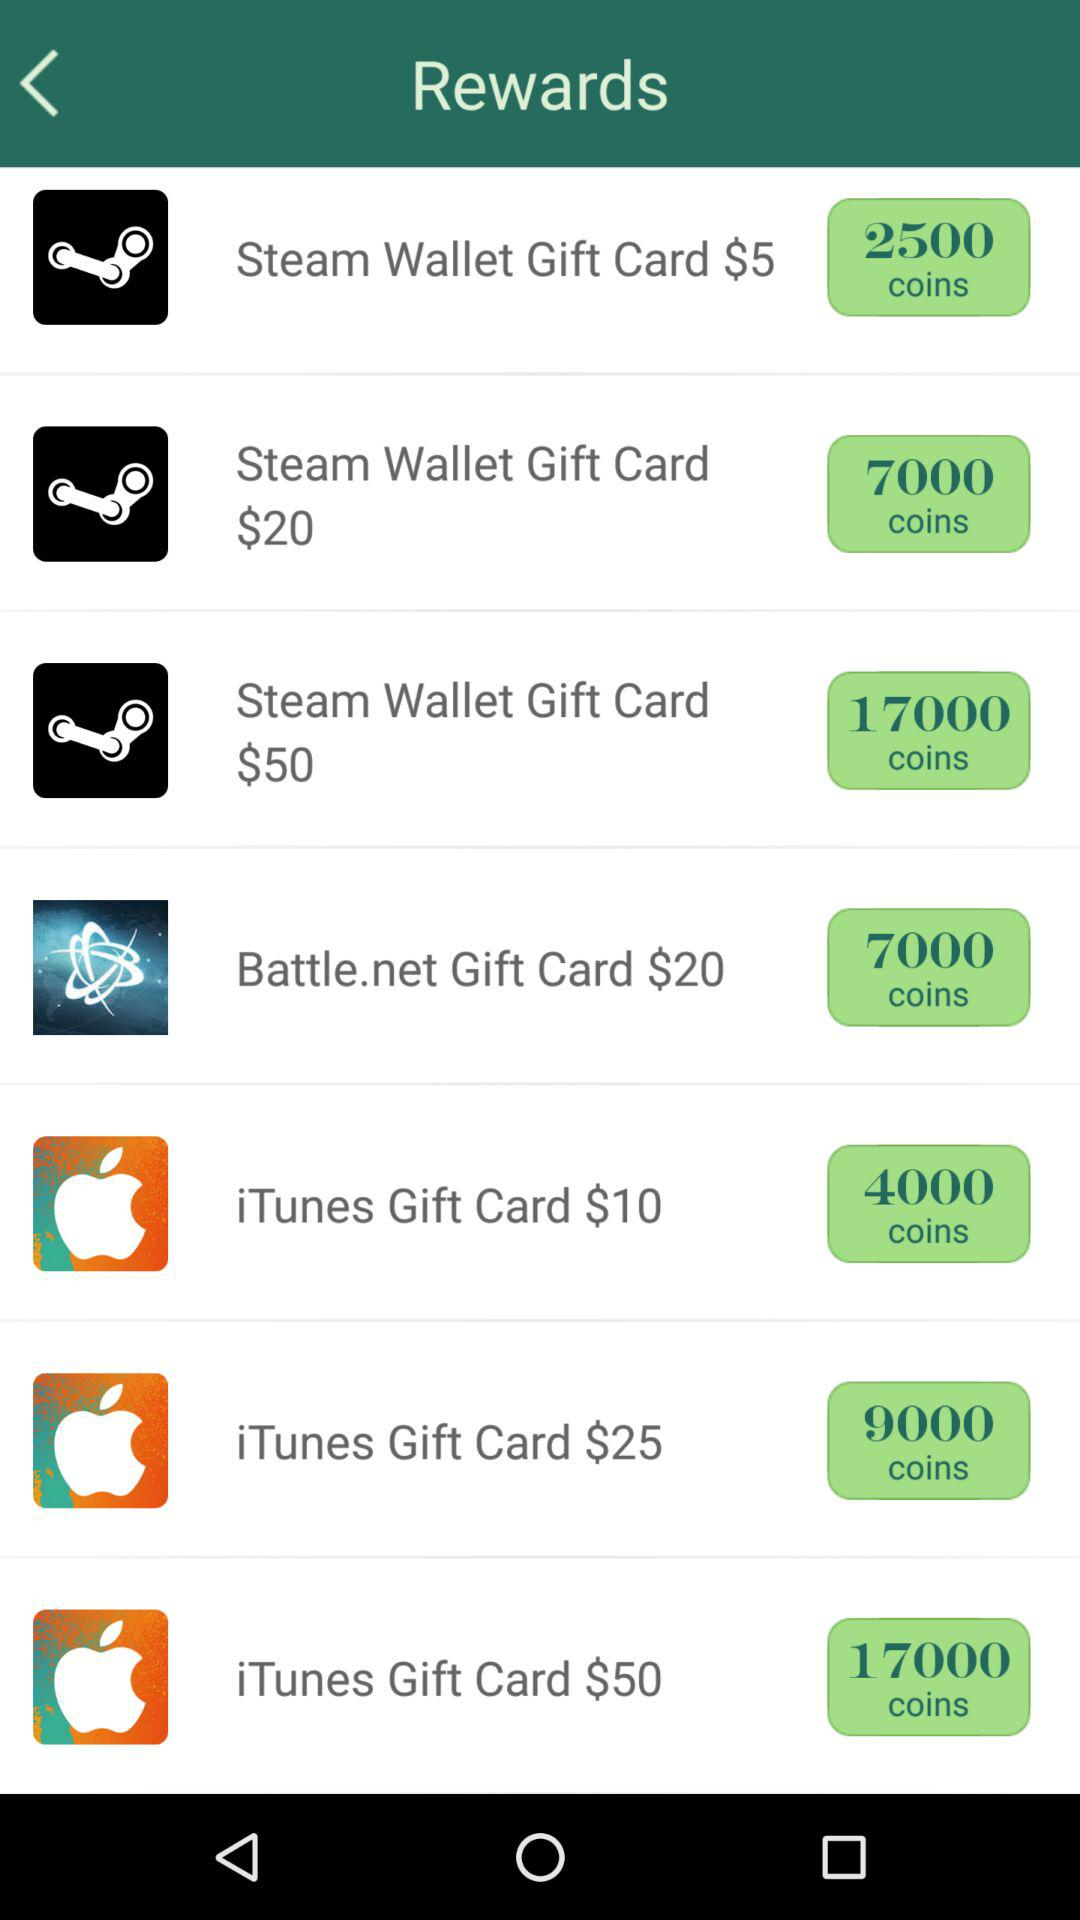How many coins do I need to buy the "Steam Wallet Gift Card $20"? You need 7000 coins to buy the "Steam Wallet Gift Card $20". 